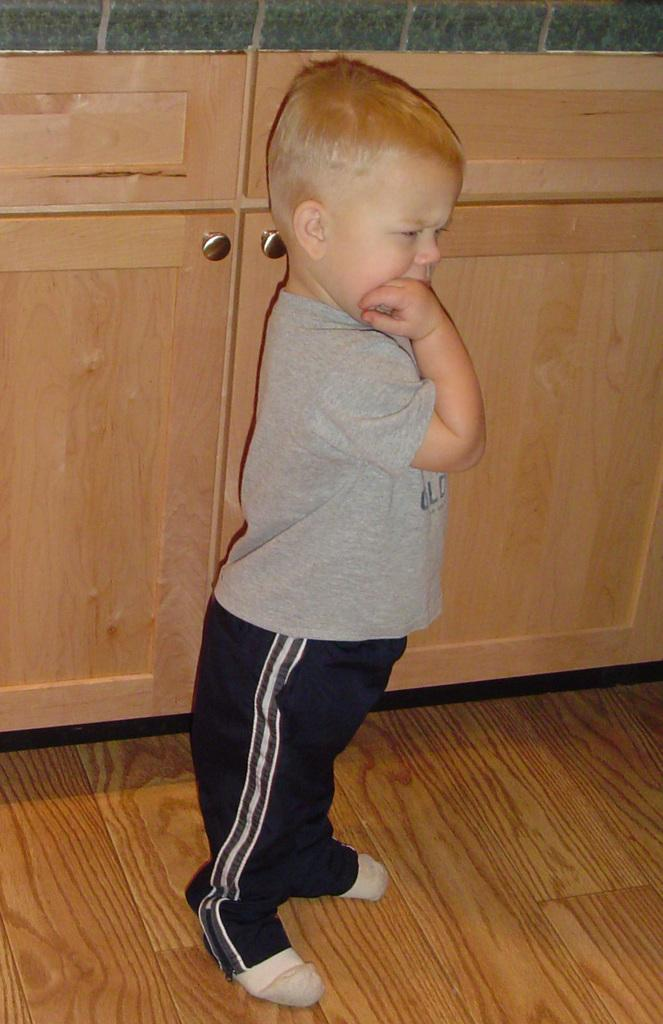What is the main subject of the image? There is a child in the image. What type of clothing is the child wearing? The child is wearing a T-shirt, pants, and socks. What type of flooring is visible in the image? The child is standing on wooden flooring. What can be seen in the background of the image? There are wooden cupboards in the background of the image. How many ladybugs are crawling on the child's T-shirt in the image? There are no ladybugs present on the child's T-shirt in the image. What type of powder is being used by the child in the image? There is no powder visible in the image, and the child is not using any powder. 